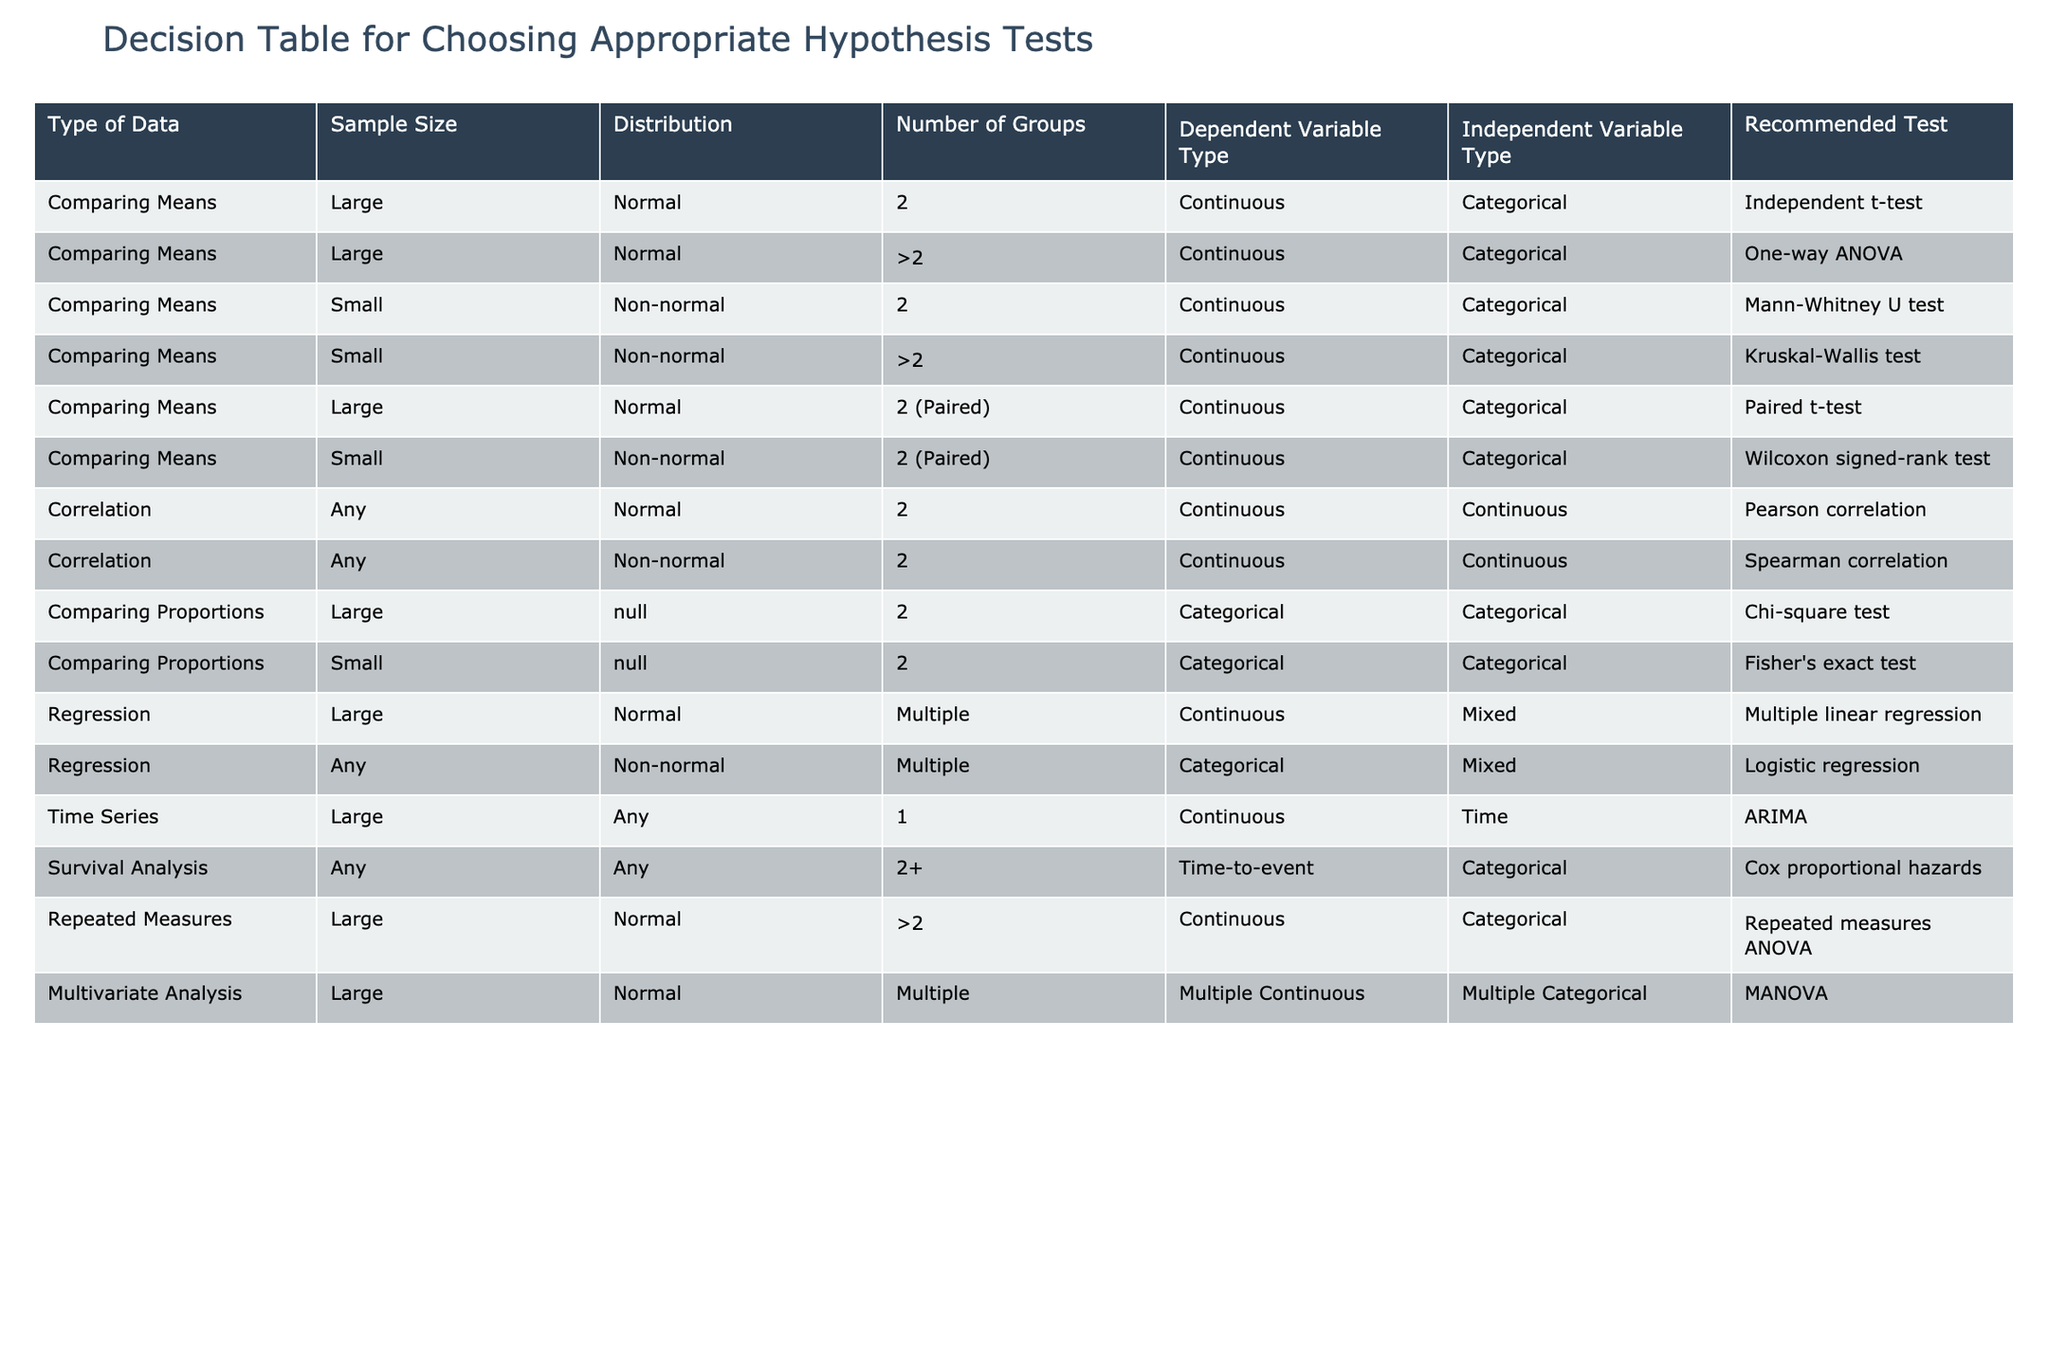What hypothesis test is recommended for comparing means of two large, normal distributions? The table specifies that for comparing means with a large sample size and normal distribution, the recommended test is the Independent t-test.
Answer: Independent t-test What type of data requires a Wilcoxon signed-rank test? According to the table, a Wilcoxon signed-rank test is recommended when the sample size is small, the distribution is non-normal, and the comparison is based on two paired continuous variables.
Answer: Small non-normal paired data Is a Chi-square test appropriate for small sample sizes? The table indicates that the Chi-square test is suitable for large sample sizes only; instead, for small sample sizes, a Fisher's exact test is recommended for comparing proportions.
Answer: No If the distribution is non-normal and there are more than two groups, which test should be applied? The table shows that when dealing with non-normal distributions and comparing more than two groups, the recommended test is the Kruskal-Wallis test.
Answer: Kruskal-Wallis test What are the recommended tests for correlation analysis? For correlation analysis, if the data is normally distributed, a Pearson correlation is recommended, while a Spearman correlation is suggested for non-normal distributions.
Answer: Pearson for normal, Spearman for non-normal What is the difference between multiple linear regression and logistic regression? The table notes that multiple linear regression is recommended for large normal datasets with continuous dependent variables, while logistic regression is used for non-normal distributions where the dependent variable is categorical.
Answer: Large normal for linear, non-normal categorical for logistic What is the appropriate test for survival analysis involving more than two groups? The table states that the Cox proportional hazards test is recommended for survival analysis when analyzing time-to-event data across two or more groups.
Answer: Cox proportional hazards Can repetitive measures ANOVA be applied to small sample sizes? Based on the information in the table, repeated measures ANOVA is not specified for small sample sizes; it is recommended for large sample sizes with a normal distribution.
Answer: No Which test should be used for time series data with a large sample size? The table specifies that for time series data with a large sample size, the ARIMA model is the recommended test.
Answer: ARIMA 